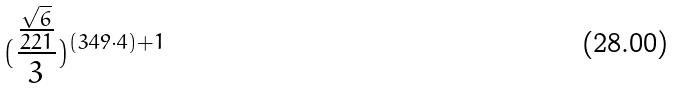Convert formula to latex. <formula><loc_0><loc_0><loc_500><loc_500>( \frac { \frac { \sqrt { 6 } } { 2 2 1 } } { 3 } ) ^ { ( 3 4 9 \cdot 4 ) + 1 }</formula> 